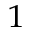<formula> <loc_0><loc_0><loc_500><loc_500>_ { 1 }</formula> 